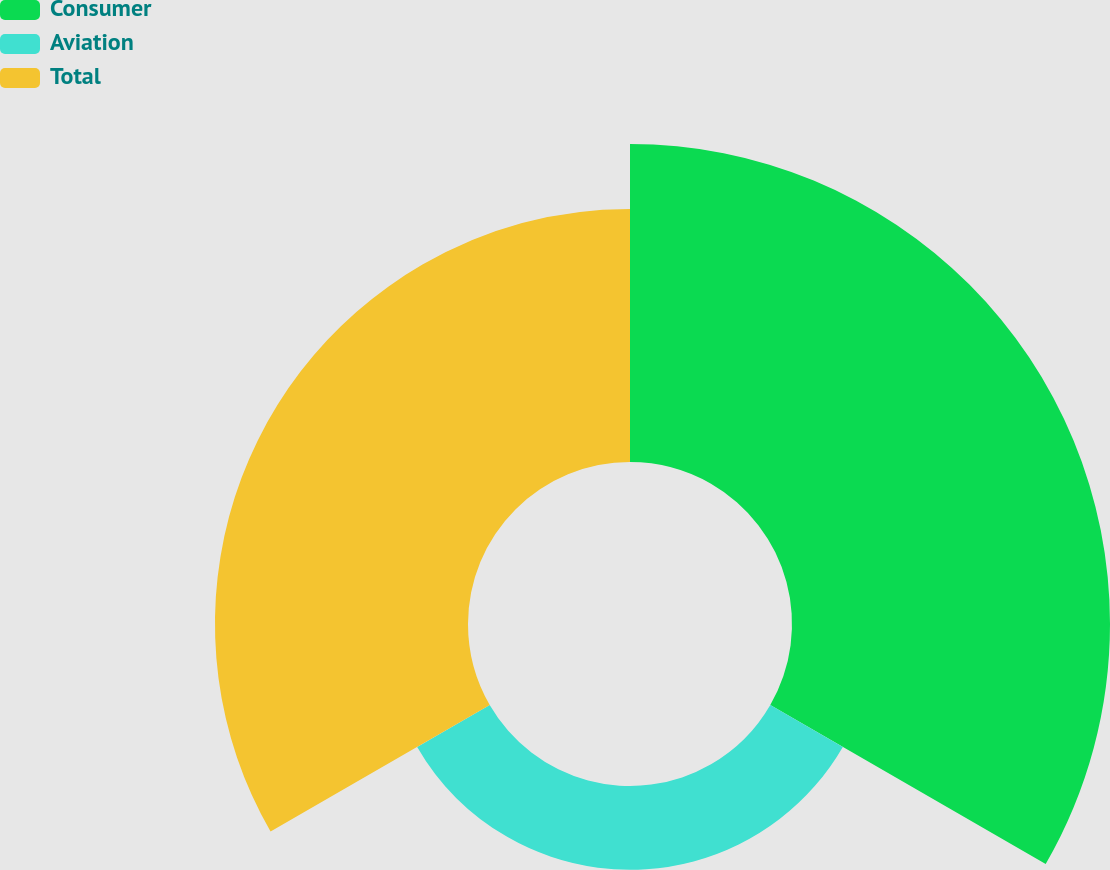<chart> <loc_0><loc_0><loc_500><loc_500><pie_chart><fcel>Consumer<fcel>Aviation<fcel>Total<nl><fcel>48.56%<fcel>12.79%<fcel>38.64%<nl></chart> 